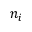<formula> <loc_0><loc_0><loc_500><loc_500>n _ { i }</formula> 